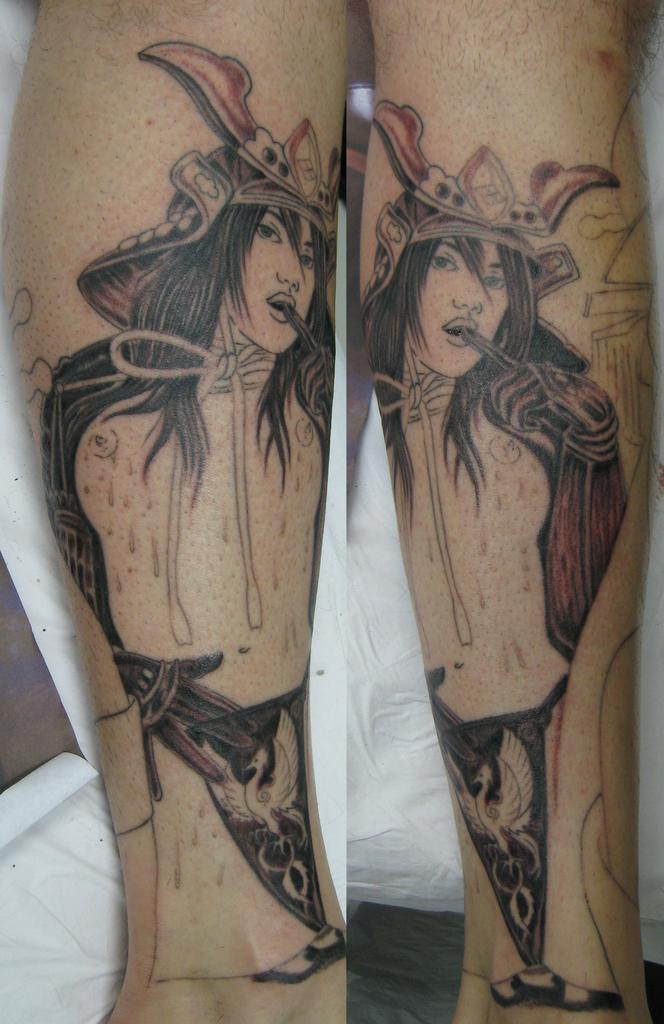What body part is visible in the image? There are legs visible in the image. What is depicted on the legs? There is an art of a person on the legs. What can be seen in the background of the image? There is a white cloth in the background of the image. What type of throne is present in the image? There is no throne present in the image; it features legs with an art of a person and a white cloth in the background. 